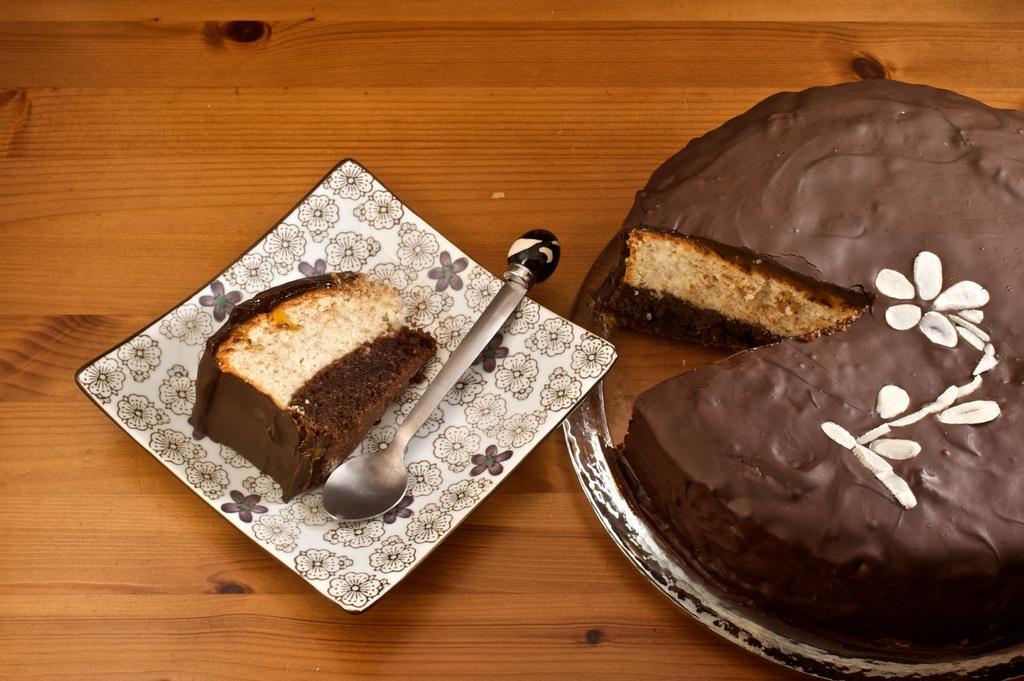Could you give a brief overview of what you see in this image? In this image we can see a plate containing a piece of cake and a spoon which is placed on the wooden surface. On the right side of the image we can see a cake in a plate. 